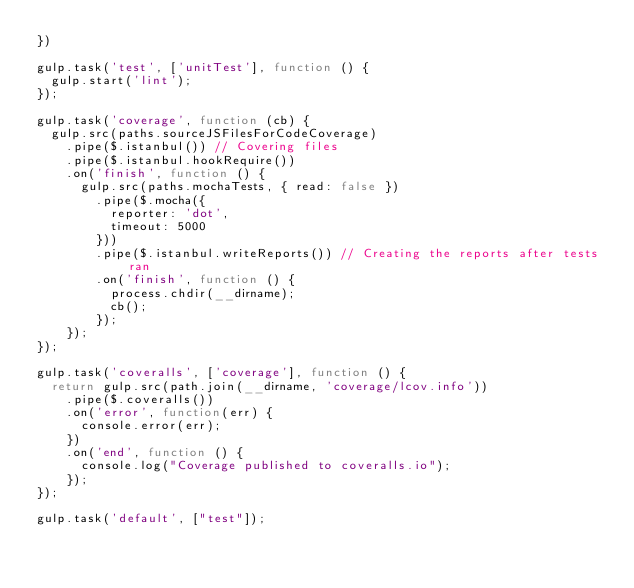<code> <loc_0><loc_0><loc_500><loc_500><_JavaScript_>})

gulp.task('test', ['unitTest'], function () {
  gulp.start('lint');
});

gulp.task('coverage', function (cb) {
  gulp.src(paths.sourceJSFilesForCodeCoverage)
    .pipe($.istanbul()) // Covering files
    .pipe($.istanbul.hookRequire())
    .on('finish', function () {
      gulp.src(paths.mochaTests, { read: false })
        .pipe($.mocha({
          reporter: 'dot',
          timeout: 5000
        }))
        .pipe($.istanbul.writeReports()) // Creating the reports after tests ran
        .on('finish', function () {
          process.chdir(__dirname);
          cb();
        });
    });
});

gulp.task('coveralls', ['coverage'], function () {
  return gulp.src(path.join(__dirname, 'coverage/lcov.info'))
    .pipe($.coveralls())
    .on('error', function(err) {
      console.error(err);
    })
    .on('end', function () {
      console.log("Coverage published to coveralls.io");
    });
});

gulp.task('default', ["test"]);
</code> 